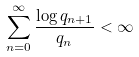<formula> <loc_0><loc_0><loc_500><loc_500>\sum _ { n = 0 } ^ { \infty } \frac { \log q _ { n + 1 } } { q _ { n } } < \infty</formula> 